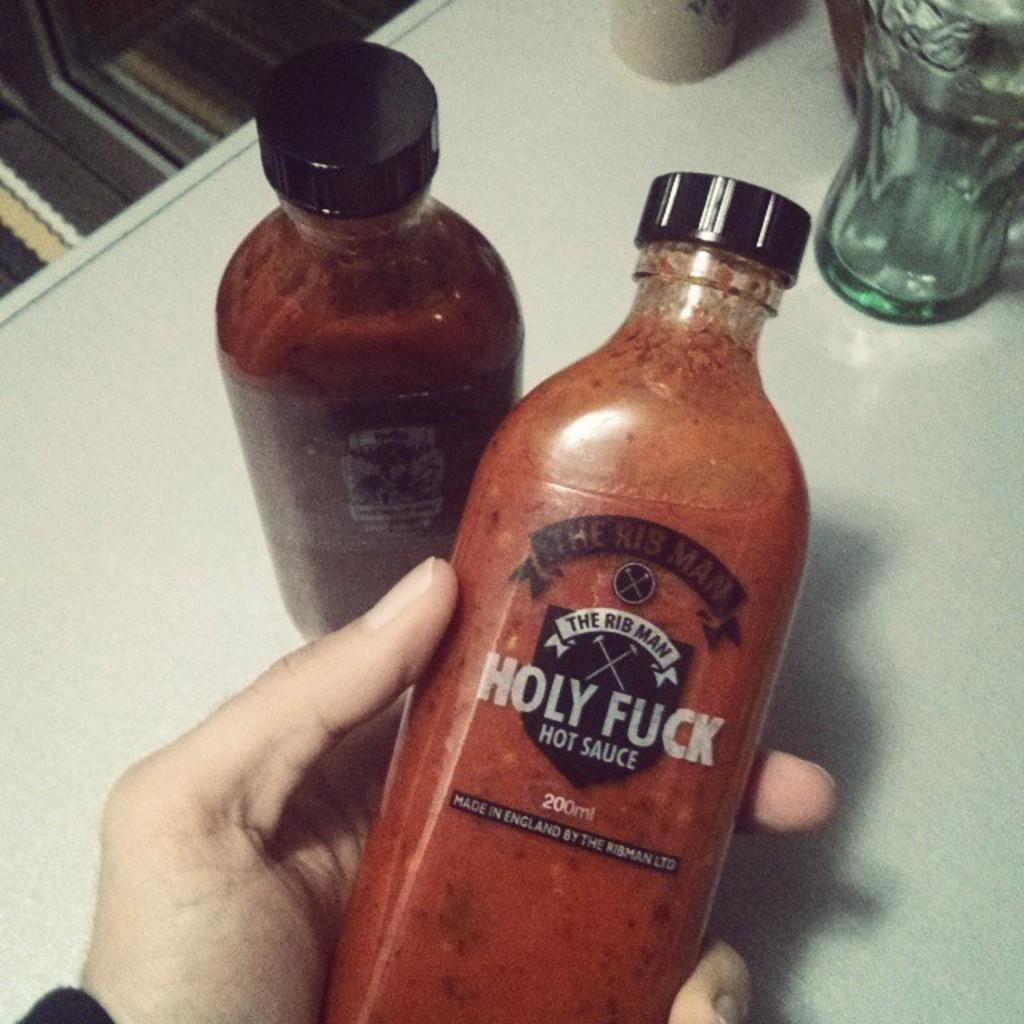<image>
Present a compact description of the photo's key features. Two bottles one of which is in a hand that say Holy Fuck Hot Sauce. 